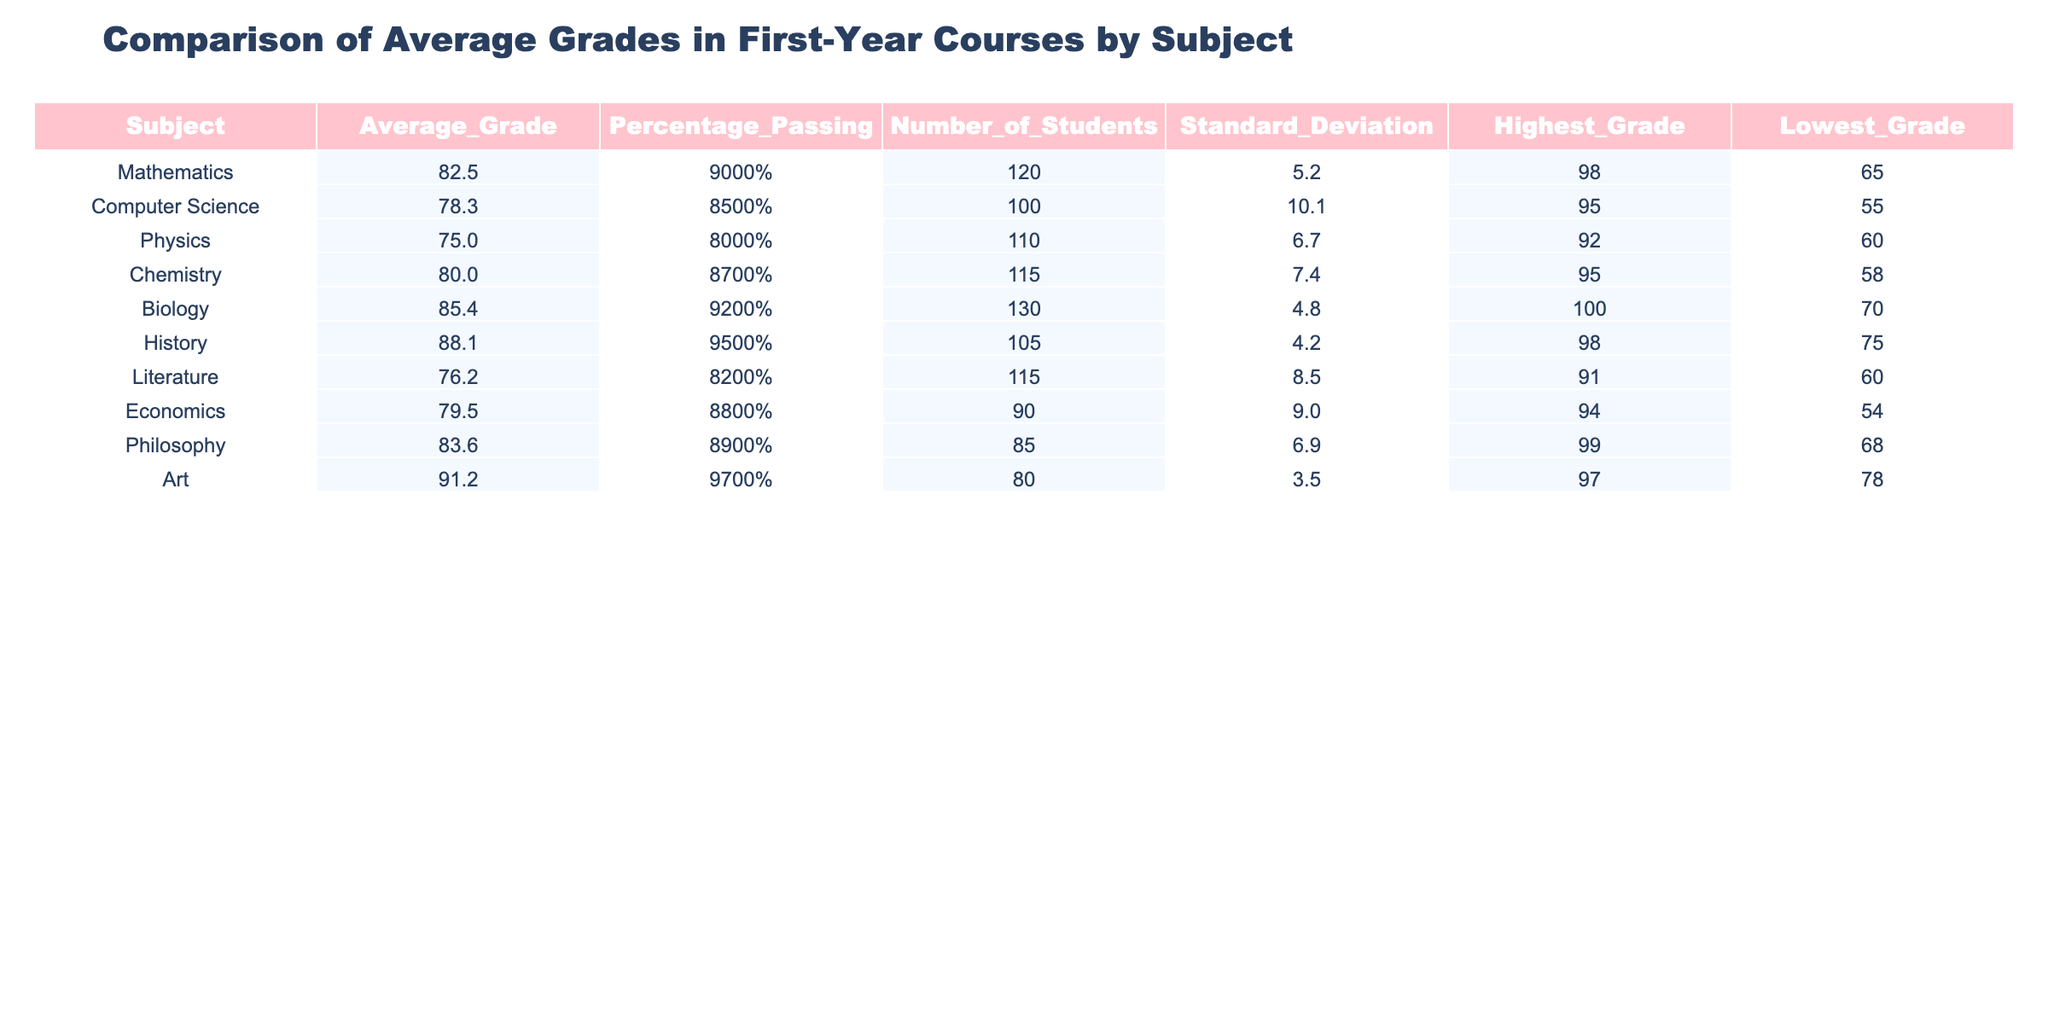What is the highest average grade among the subjects? The table shows the average grades, and the highest value is found by looking through the column. The highest average grade is in Art, which is 91.2.
Answer: 91.2 Which subject has the lowest average grade? To find the lowest average grade, I check the values in the Average_Grade column. The lowest value is in Physics, which is 75.0.
Answer: 75.0 How many students are enrolled in the Biology course? The table displays the Number_of_Students for each subject. For Biology, the value is 130.
Answer: 130 What is the percentage of students passing in Philosophy? From the Percentage_Passing column, I look for the value associated with Philosophy, which is 89%.
Answer: 89% Which subject has the highest percentage of passing students? I compare the Percentage_Passing values across all subjects. The highest is in History at 95%.
Answer: 95% What is the difference in average grades between Mathematics and Chemistry? The average grade for Mathematics is 82.5, and for Chemistry, it is 80.0. The difference is calculated as 82.5 - 80.0 = 2.5.
Answer: 2.5 Is the percentage of passing students in Biology greater than in Computer Science? By comparing the Percentage_Passing values, Biology has 92% and Computer Science has 85%. Since 92% is greater than 85%, the statement is true.
Answer: Yes Which subject had the lowest grade? The Lowest_Grade column states that Literature has the lowest grade of 60.
Answer: 60 What is the average standard deviation of the grades across all subjects? To calculate the average standard deviation, I first find the standard deviations listed: 5.2, 10.1, 6.7, 7.4, 4.8, 4.2, 8.5, 9.0, 6.9, and 3.5. Summing these gives a total of 57.9, then dividing by the number of subjects (10) gives an average of 5.79.
Answer: 5.79 Which subject has a higher average grade, Literature or Physics? I find the average grades: Literature has 76.2 and Physics has 75.0. Comparing the two, Literature is higher.
Answer: Literature 